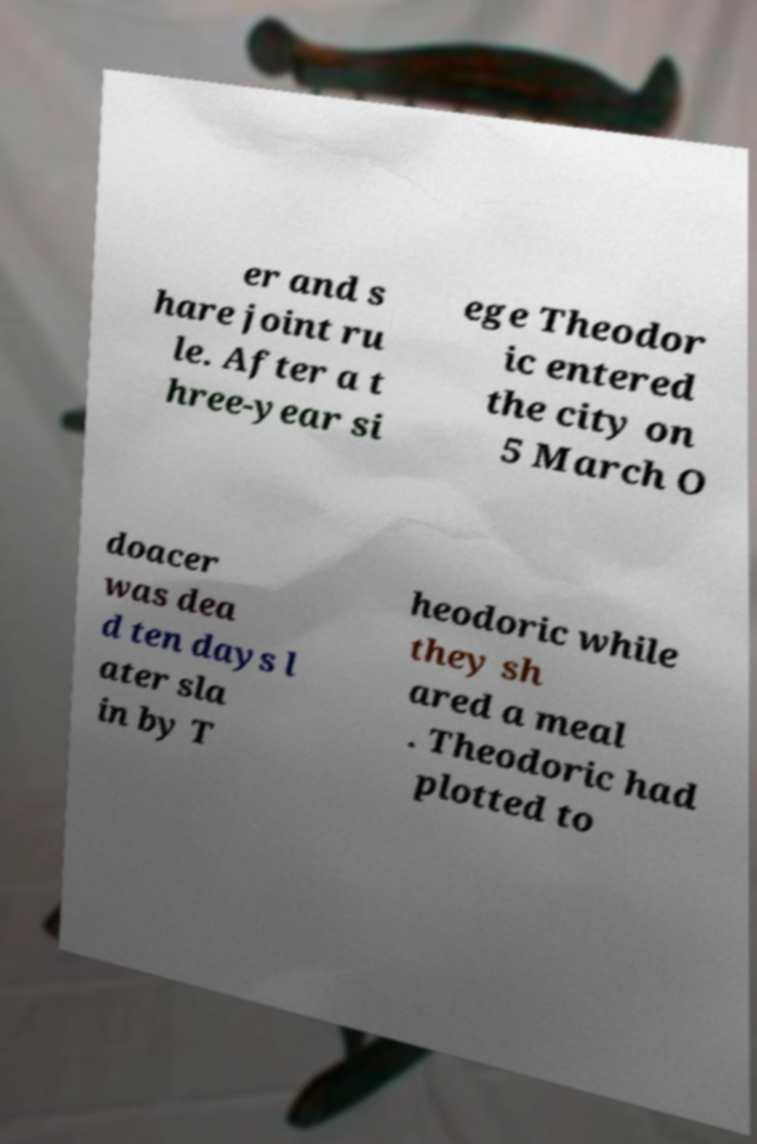Please identify and transcribe the text found in this image. er and s hare joint ru le. After a t hree-year si ege Theodor ic entered the city on 5 March O doacer was dea d ten days l ater sla in by T heodoric while they sh ared a meal . Theodoric had plotted to 